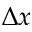Convert formula to latex. <formula><loc_0><loc_0><loc_500><loc_500>\Delta x</formula> 